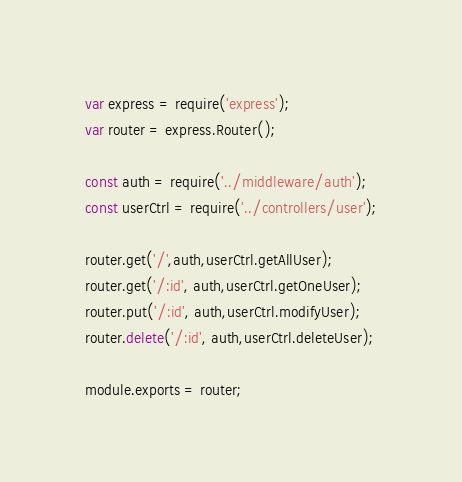<code> <loc_0><loc_0><loc_500><loc_500><_JavaScript_>var express = require('express');
var router = express.Router();

const auth = require('../middleware/auth');
const userCtrl = require('../controllers/user');

router.get('/',auth,userCtrl.getAllUser);
router.get('/:id', auth,userCtrl.getOneUser);
router.put('/:id', auth,userCtrl.modifyUser);
router.delete('/:id', auth,userCtrl.deleteUser);

module.exports = router;

</code> 